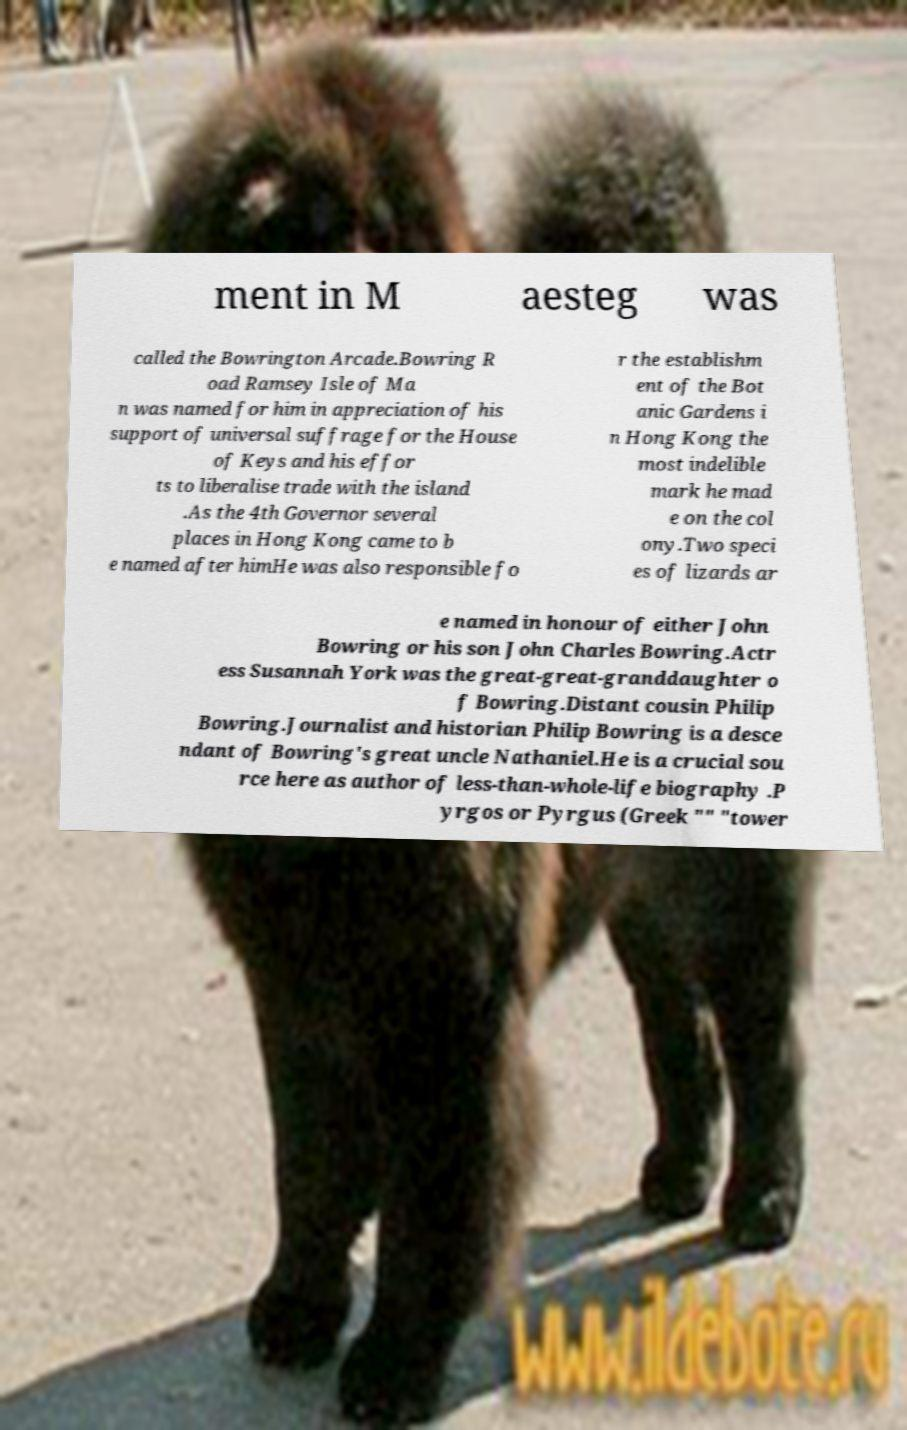I need the written content from this picture converted into text. Can you do that? ment in M aesteg was called the Bowrington Arcade.Bowring R oad Ramsey Isle of Ma n was named for him in appreciation of his support of universal suffrage for the House of Keys and his effor ts to liberalise trade with the island .As the 4th Governor several places in Hong Kong came to b e named after himHe was also responsible fo r the establishm ent of the Bot anic Gardens i n Hong Kong the most indelible mark he mad e on the col ony.Two speci es of lizards ar e named in honour of either John Bowring or his son John Charles Bowring.Actr ess Susannah York was the great-great-granddaughter o f Bowring.Distant cousin Philip Bowring.Journalist and historian Philip Bowring is a desce ndant of Bowring's great uncle Nathaniel.He is a crucial sou rce here as author of less-than-whole-life biography .P yrgos or Pyrgus (Greek "" "tower 